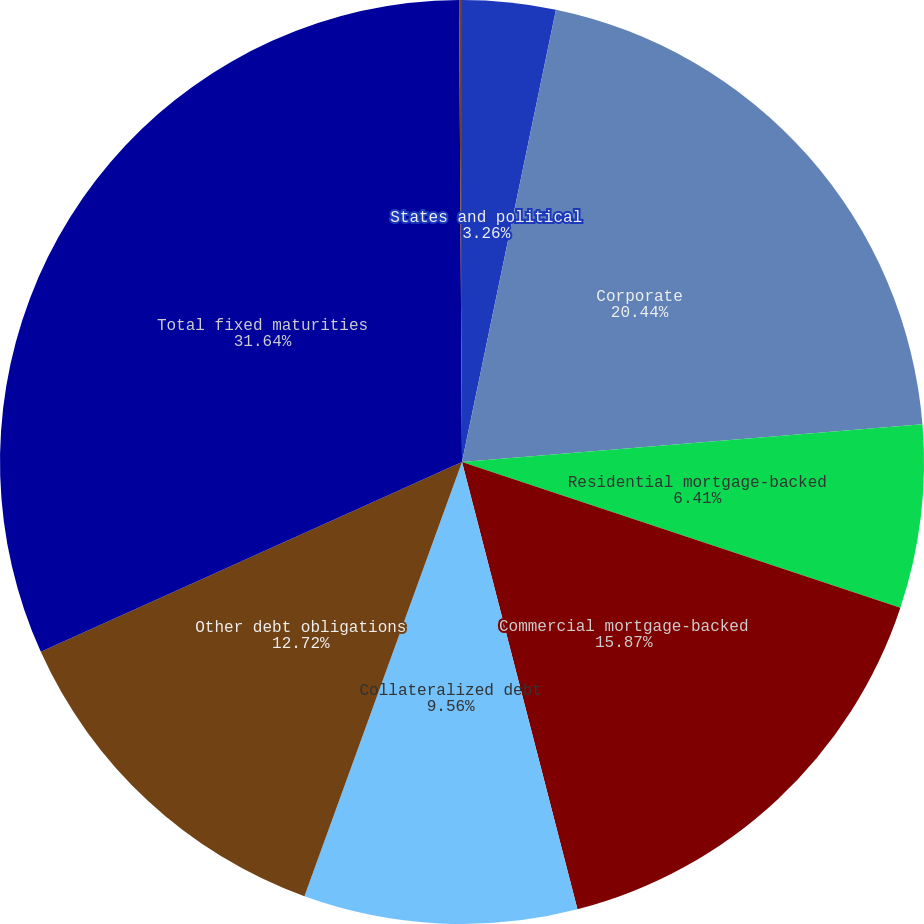Convert chart to OTSL. <chart><loc_0><loc_0><loc_500><loc_500><pie_chart><fcel>States and political<fcel>Corporate<fcel>Residential mortgage-backed<fcel>Commercial mortgage-backed<fcel>Collateralized debt<fcel>Other debt obligations<fcel>Total fixed maturities<fcel>Total equity securities<nl><fcel>3.26%<fcel>20.44%<fcel>6.41%<fcel>15.87%<fcel>9.56%<fcel>12.72%<fcel>31.64%<fcel>0.1%<nl></chart> 